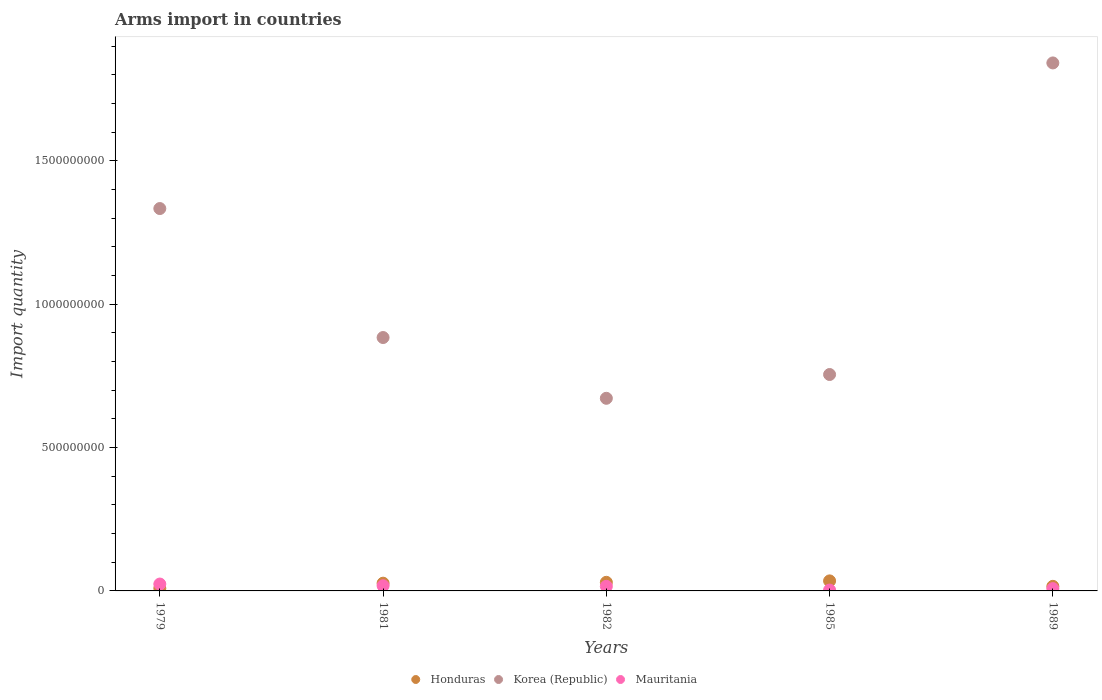What is the total arms import in Korea (Republic) in 1979?
Offer a very short reply. 1.33e+09. Across all years, what is the maximum total arms import in Mauritania?
Offer a very short reply. 2.40e+07. In which year was the total arms import in Mauritania maximum?
Keep it short and to the point. 1979. What is the total total arms import in Honduras in the graph?
Offer a terse response. 1.17e+08. What is the difference between the total arms import in Mauritania in 1979 and that in 1985?
Your answer should be very brief. 2.10e+07. What is the difference between the total arms import in Mauritania in 1981 and the total arms import in Korea (Republic) in 1982?
Offer a very short reply. -6.54e+08. What is the average total arms import in Honduras per year?
Your response must be concise. 2.34e+07. In the year 1982, what is the difference between the total arms import in Korea (Republic) and total arms import in Honduras?
Provide a succinct answer. 6.42e+08. What is the ratio of the total arms import in Mauritania in 1981 to that in 1989?
Your answer should be very brief. 2.25. Is the difference between the total arms import in Korea (Republic) in 1979 and 1989 greater than the difference between the total arms import in Honduras in 1979 and 1989?
Provide a succinct answer. No. What is the difference between the highest and the second highest total arms import in Honduras?
Offer a terse response. 5.00e+06. What is the difference between the highest and the lowest total arms import in Mauritania?
Your response must be concise. 2.10e+07. In how many years, is the total arms import in Korea (Republic) greater than the average total arms import in Korea (Republic) taken over all years?
Your answer should be very brief. 2. Is it the case that in every year, the sum of the total arms import in Honduras and total arms import in Mauritania  is greater than the total arms import in Korea (Republic)?
Give a very brief answer. No. Is the total arms import in Honduras strictly less than the total arms import in Korea (Republic) over the years?
Make the answer very short. Yes. How many years are there in the graph?
Offer a very short reply. 5. What is the difference between two consecutive major ticks on the Y-axis?
Make the answer very short. 5.00e+08. Are the values on the major ticks of Y-axis written in scientific E-notation?
Your response must be concise. No. Does the graph contain any zero values?
Your answer should be very brief. No. Where does the legend appear in the graph?
Your response must be concise. Bottom center. How many legend labels are there?
Offer a terse response. 3. What is the title of the graph?
Offer a terse response. Arms import in countries. What is the label or title of the Y-axis?
Offer a terse response. Import quantity. What is the Import quantity in Honduras in 1979?
Offer a very short reply. 9.00e+06. What is the Import quantity in Korea (Republic) in 1979?
Your answer should be very brief. 1.33e+09. What is the Import quantity in Mauritania in 1979?
Ensure brevity in your answer.  2.40e+07. What is the Import quantity of Honduras in 1981?
Give a very brief answer. 2.70e+07. What is the Import quantity of Korea (Republic) in 1981?
Your response must be concise. 8.84e+08. What is the Import quantity of Mauritania in 1981?
Make the answer very short. 1.80e+07. What is the Import quantity of Honduras in 1982?
Your answer should be compact. 3.00e+07. What is the Import quantity in Korea (Republic) in 1982?
Your answer should be compact. 6.72e+08. What is the Import quantity of Mauritania in 1982?
Ensure brevity in your answer.  1.60e+07. What is the Import quantity in Honduras in 1985?
Offer a terse response. 3.50e+07. What is the Import quantity in Korea (Republic) in 1985?
Provide a succinct answer. 7.55e+08. What is the Import quantity in Mauritania in 1985?
Your response must be concise. 3.00e+06. What is the Import quantity in Honduras in 1989?
Give a very brief answer. 1.60e+07. What is the Import quantity in Korea (Republic) in 1989?
Keep it short and to the point. 1.84e+09. Across all years, what is the maximum Import quantity of Honduras?
Keep it short and to the point. 3.50e+07. Across all years, what is the maximum Import quantity in Korea (Republic)?
Keep it short and to the point. 1.84e+09. Across all years, what is the maximum Import quantity in Mauritania?
Provide a short and direct response. 2.40e+07. Across all years, what is the minimum Import quantity of Honduras?
Offer a terse response. 9.00e+06. Across all years, what is the minimum Import quantity in Korea (Republic)?
Make the answer very short. 6.72e+08. What is the total Import quantity in Honduras in the graph?
Provide a succinct answer. 1.17e+08. What is the total Import quantity of Korea (Republic) in the graph?
Offer a terse response. 5.49e+09. What is the total Import quantity in Mauritania in the graph?
Ensure brevity in your answer.  6.90e+07. What is the difference between the Import quantity of Honduras in 1979 and that in 1981?
Offer a very short reply. -1.80e+07. What is the difference between the Import quantity in Korea (Republic) in 1979 and that in 1981?
Provide a succinct answer. 4.50e+08. What is the difference between the Import quantity in Honduras in 1979 and that in 1982?
Keep it short and to the point. -2.10e+07. What is the difference between the Import quantity in Korea (Republic) in 1979 and that in 1982?
Your answer should be compact. 6.62e+08. What is the difference between the Import quantity of Mauritania in 1979 and that in 1982?
Give a very brief answer. 8.00e+06. What is the difference between the Import quantity of Honduras in 1979 and that in 1985?
Offer a terse response. -2.60e+07. What is the difference between the Import quantity of Korea (Republic) in 1979 and that in 1985?
Your answer should be very brief. 5.79e+08. What is the difference between the Import quantity in Mauritania in 1979 and that in 1985?
Provide a succinct answer. 2.10e+07. What is the difference between the Import quantity of Honduras in 1979 and that in 1989?
Give a very brief answer. -7.00e+06. What is the difference between the Import quantity of Korea (Republic) in 1979 and that in 1989?
Provide a short and direct response. -5.08e+08. What is the difference between the Import quantity in Mauritania in 1979 and that in 1989?
Keep it short and to the point. 1.60e+07. What is the difference between the Import quantity of Korea (Republic) in 1981 and that in 1982?
Offer a very short reply. 2.12e+08. What is the difference between the Import quantity in Mauritania in 1981 and that in 1982?
Provide a succinct answer. 2.00e+06. What is the difference between the Import quantity of Honduras in 1981 and that in 1985?
Ensure brevity in your answer.  -8.00e+06. What is the difference between the Import quantity in Korea (Republic) in 1981 and that in 1985?
Keep it short and to the point. 1.29e+08. What is the difference between the Import quantity of Mauritania in 1981 and that in 1985?
Give a very brief answer. 1.50e+07. What is the difference between the Import quantity of Honduras in 1981 and that in 1989?
Make the answer very short. 1.10e+07. What is the difference between the Import quantity of Korea (Republic) in 1981 and that in 1989?
Provide a succinct answer. -9.58e+08. What is the difference between the Import quantity of Honduras in 1982 and that in 1985?
Keep it short and to the point. -5.00e+06. What is the difference between the Import quantity in Korea (Republic) in 1982 and that in 1985?
Give a very brief answer. -8.30e+07. What is the difference between the Import quantity in Mauritania in 1982 and that in 1985?
Give a very brief answer. 1.30e+07. What is the difference between the Import quantity of Honduras in 1982 and that in 1989?
Offer a very short reply. 1.40e+07. What is the difference between the Import quantity of Korea (Republic) in 1982 and that in 1989?
Offer a terse response. -1.17e+09. What is the difference between the Import quantity in Honduras in 1985 and that in 1989?
Give a very brief answer. 1.90e+07. What is the difference between the Import quantity in Korea (Republic) in 1985 and that in 1989?
Provide a short and direct response. -1.09e+09. What is the difference between the Import quantity in Mauritania in 1985 and that in 1989?
Offer a very short reply. -5.00e+06. What is the difference between the Import quantity in Honduras in 1979 and the Import quantity in Korea (Republic) in 1981?
Give a very brief answer. -8.75e+08. What is the difference between the Import quantity of Honduras in 1979 and the Import quantity of Mauritania in 1981?
Ensure brevity in your answer.  -9.00e+06. What is the difference between the Import quantity in Korea (Republic) in 1979 and the Import quantity in Mauritania in 1981?
Offer a very short reply. 1.32e+09. What is the difference between the Import quantity of Honduras in 1979 and the Import quantity of Korea (Republic) in 1982?
Your answer should be compact. -6.63e+08. What is the difference between the Import quantity of Honduras in 1979 and the Import quantity of Mauritania in 1982?
Your answer should be very brief. -7.00e+06. What is the difference between the Import quantity of Korea (Republic) in 1979 and the Import quantity of Mauritania in 1982?
Your response must be concise. 1.32e+09. What is the difference between the Import quantity of Honduras in 1979 and the Import quantity of Korea (Republic) in 1985?
Provide a short and direct response. -7.46e+08. What is the difference between the Import quantity in Honduras in 1979 and the Import quantity in Mauritania in 1985?
Your answer should be compact. 6.00e+06. What is the difference between the Import quantity in Korea (Republic) in 1979 and the Import quantity in Mauritania in 1985?
Offer a very short reply. 1.33e+09. What is the difference between the Import quantity of Honduras in 1979 and the Import quantity of Korea (Republic) in 1989?
Ensure brevity in your answer.  -1.83e+09. What is the difference between the Import quantity of Honduras in 1979 and the Import quantity of Mauritania in 1989?
Offer a terse response. 1.00e+06. What is the difference between the Import quantity of Korea (Republic) in 1979 and the Import quantity of Mauritania in 1989?
Give a very brief answer. 1.33e+09. What is the difference between the Import quantity of Honduras in 1981 and the Import quantity of Korea (Republic) in 1982?
Give a very brief answer. -6.45e+08. What is the difference between the Import quantity in Honduras in 1981 and the Import quantity in Mauritania in 1982?
Offer a terse response. 1.10e+07. What is the difference between the Import quantity in Korea (Republic) in 1981 and the Import quantity in Mauritania in 1982?
Give a very brief answer. 8.68e+08. What is the difference between the Import quantity of Honduras in 1981 and the Import quantity of Korea (Republic) in 1985?
Your response must be concise. -7.28e+08. What is the difference between the Import quantity in Honduras in 1981 and the Import quantity in Mauritania in 1985?
Provide a short and direct response. 2.40e+07. What is the difference between the Import quantity in Korea (Republic) in 1981 and the Import quantity in Mauritania in 1985?
Give a very brief answer. 8.81e+08. What is the difference between the Import quantity in Honduras in 1981 and the Import quantity in Korea (Republic) in 1989?
Your answer should be very brief. -1.82e+09. What is the difference between the Import quantity in Honduras in 1981 and the Import quantity in Mauritania in 1989?
Your response must be concise. 1.90e+07. What is the difference between the Import quantity in Korea (Republic) in 1981 and the Import quantity in Mauritania in 1989?
Your answer should be very brief. 8.76e+08. What is the difference between the Import quantity of Honduras in 1982 and the Import quantity of Korea (Republic) in 1985?
Give a very brief answer. -7.25e+08. What is the difference between the Import quantity of Honduras in 1982 and the Import quantity of Mauritania in 1985?
Provide a short and direct response. 2.70e+07. What is the difference between the Import quantity of Korea (Republic) in 1982 and the Import quantity of Mauritania in 1985?
Offer a terse response. 6.69e+08. What is the difference between the Import quantity of Honduras in 1982 and the Import quantity of Korea (Republic) in 1989?
Your answer should be very brief. -1.81e+09. What is the difference between the Import quantity of Honduras in 1982 and the Import quantity of Mauritania in 1989?
Offer a very short reply. 2.20e+07. What is the difference between the Import quantity in Korea (Republic) in 1982 and the Import quantity in Mauritania in 1989?
Give a very brief answer. 6.64e+08. What is the difference between the Import quantity in Honduras in 1985 and the Import quantity in Korea (Republic) in 1989?
Give a very brief answer. -1.81e+09. What is the difference between the Import quantity in Honduras in 1985 and the Import quantity in Mauritania in 1989?
Provide a short and direct response. 2.70e+07. What is the difference between the Import quantity of Korea (Republic) in 1985 and the Import quantity of Mauritania in 1989?
Your response must be concise. 7.47e+08. What is the average Import quantity of Honduras per year?
Provide a succinct answer. 2.34e+07. What is the average Import quantity in Korea (Republic) per year?
Your answer should be compact. 1.10e+09. What is the average Import quantity of Mauritania per year?
Make the answer very short. 1.38e+07. In the year 1979, what is the difference between the Import quantity in Honduras and Import quantity in Korea (Republic)?
Give a very brief answer. -1.32e+09. In the year 1979, what is the difference between the Import quantity of Honduras and Import quantity of Mauritania?
Keep it short and to the point. -1.50e+07. In the year 1979, what is the difference between the Import quantity in Korea (Republic) and Import quantity in Mauritania?
Your answer should be compact. 1.31e+09. In the year 1981, what is the difference between the Import quantity of Honduras and Import quantity of Korea (Republic)?
Make the answer very short. -8.57e+08. In the year 1981, what is the difference between the Import quantity of Honduras and Import quantity of Mauritania?
Provide a succinct answer. 9.00e+06. In the year 1981, what is the difference between the Import quantity in Korea (Republic) and Import quantity in Mauritania?
Offer a very short reply. 8.66e+08. In the year 1982, what is the difference between the Import quantity in Honduras and Import quantity in Korea (Republic)?
Offer a very short reply. -6.42e+08. In the year 1982, what is the difference between the Import quantity of Honduras and Import quantity of Mauritania?
Give a very brief answer. 1.40e+07. In the year 1982, what is the difference between the Import quantity of Korea (Republic) and Import quantity of Mauritania?
Your response must be concise. 6.56e+08. In the year 1985, what is the difference between the Import quantity of Honduras and Import quantity of Korea (Republic)?
Offer a very short reply. -7.20e+08. In the year 1985, what is the difference between the Import quantity in Honduras and Import quantity in Mauritania?
Your answer should be compact. 3.20e+07. In the year 1985, what is the difference between the Import quantity in Korea (Republic) and Import quantity in Mauritania?
Your answer should be compact. 7.52e+08. In the year 1989, what is the difference between the Import quantity in Honduras and Import quantity in Korea (Republic)?
Ensure brevity in your answer.  -1.83e+09. In the year 1989, what is the difference between the Import quantity in Korea (Republic) and Import quantity in Mauritania?
Your answer should be compact. 1.83e+09. What is the ratio of the Import quantity in Honduras in 1979 to that in 1981?
Give a very brief answer. 0.33. What is the ratio of the Import quantity in Korea (Republic) in 1979 to that in 1981?
Keep it short and to the point. 1.51. What is the ratio of the Import quantity of Mauritania in 1979 to that in 1981?
Your answer should be very brief. 1.33. What is the ratio of the Import quantity of Honduras in 1979 to that in 1982?
Your answer should be compact. 0.3. What is the ratio of the Import quantity of Korea (Republic) in 1979 to that in 1982?
Offer a terse response. 1.99. What is the ratio of the Import quantity in Mauritania in 1979 to that in 1982?
Make the answer very short. 1.5. What is the ratio of the Import quantity in Honduras in 1979 to that in 1985?
Offer a terse response. 0.26. What is the ratio of the Import quantity of Korea (Republic) in 1979 to that in 1985?
Keep it short and to the point. 1.77. What is the ratio of the Import quantity in Honduras in 1979 to that in 1989?
Your answer should be compact. 0.56. What is the ratio of the Import quantity of Korea (Republic) in 1979 to that in 1989?
Provide a short and direct response. 0.72. What is the ratio of the Import quantity of Mauritania in 1979 to that in 1989?
Give a very brief answer. 3. What is the ratio of the Import quantity in Korea (Republic) in 1981 to that in 1982?
Offer a terse response. 1.32. What is the ratio of the Import quantity of Mauritania in 1981 to that in 1982?
Your response must be concise. 1.12. What is the ratio of the Import quantity of Honduras in 1981 to that in 1985?
Your answer should be very brief. 0.77. What is the ratio of the Import quantity in Korea (Republic) in 1981 to that in 1985?
Your answer should be very brief. 1.17. What is the ratio of the Import quantity in Honduras in 1981 to that in 1989?
Ensure brevity in your answer.  1.69. What is the ratio of the Import quantity in Korea (Republic) in 1981 to that in 1989?
Ensure brevity in your answer.  0.48. What is the ratio of the Import quantity in Mauritania in 1981 to that in 1989?
Offer a terse response. 2.25. What is the ratio of the Import quantity in Korea (Republic) in 1982 to that in 1985?
Offer a very short reply. 0.89. What is the ratio of the Import quantity of Mauritania in 1982 to that in 1985?
Your answer should be compact. 5.33. What is the ratio of the Import quantity in Honduras in 1982 to that in 1989?
Make the answer very short. 1.88. What is the ratio of the Import quantity of Korea (Republic) in 1982 to that in 1989?
Give a very brief answer. 0.36. What is the ratio of the Import quantity of Honduras in 1985 to that in 1989?
Provide a short and direct response. 2.19. What is the ratio of the Import quantity in Korea (Republic) in 1985 to that in 1989?
Provide a succinct answer. 0.41. What is the difference between the highest and the second highest Import quantity in Honduras?
Your answer should be very brief. 5.00e+06. What is the difference between the highest and the second highest Import quantity of Korea (Republic)?
Your answer should be compact. 5.08e+08. What is the difference between the highest and the lowest Import quantity of Honduras?
Your answer should be compact. 2.60e+07. What is the difference between the highest and the lowest Import quantity of Korea (Republic)?
Your answer should be very brief. 1.17e+09. What is the difference between the highest and the lowest Import quantity of Mauritania?
Your answer should be compact. 2.10e+07. 